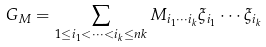Convert formula to latex. <formula><loc_0><loc_0><loc_500><loc_500>G _ { M } = \sum _ { 1 \leq i _ { 1 } < \dots < i _ { k } \leq n k } M _ { i _ { 1 } \cdots i _ { k } } \xi _ { i _ { 1 } } \cdots \xi _ { i _ { k } }</formula> 